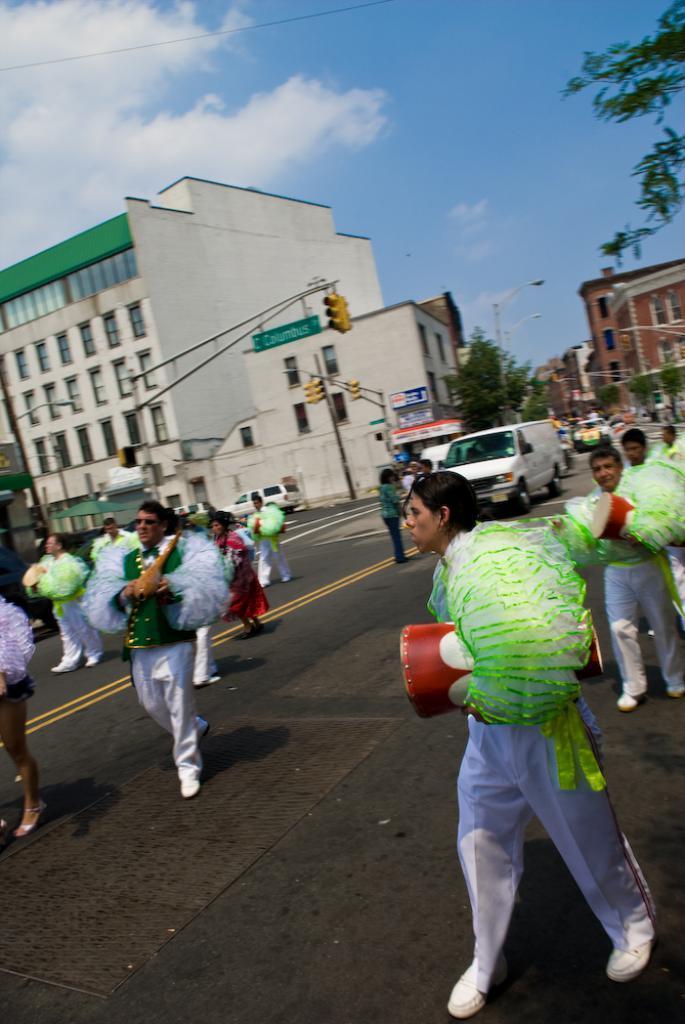Can you describe this image briefly? Here a person is walking on the road, this person wore white color dress, holding a green color thing. In the middle a car is moving it is in white color. On the left side there are buildings. At the top it is the blue color sky. 